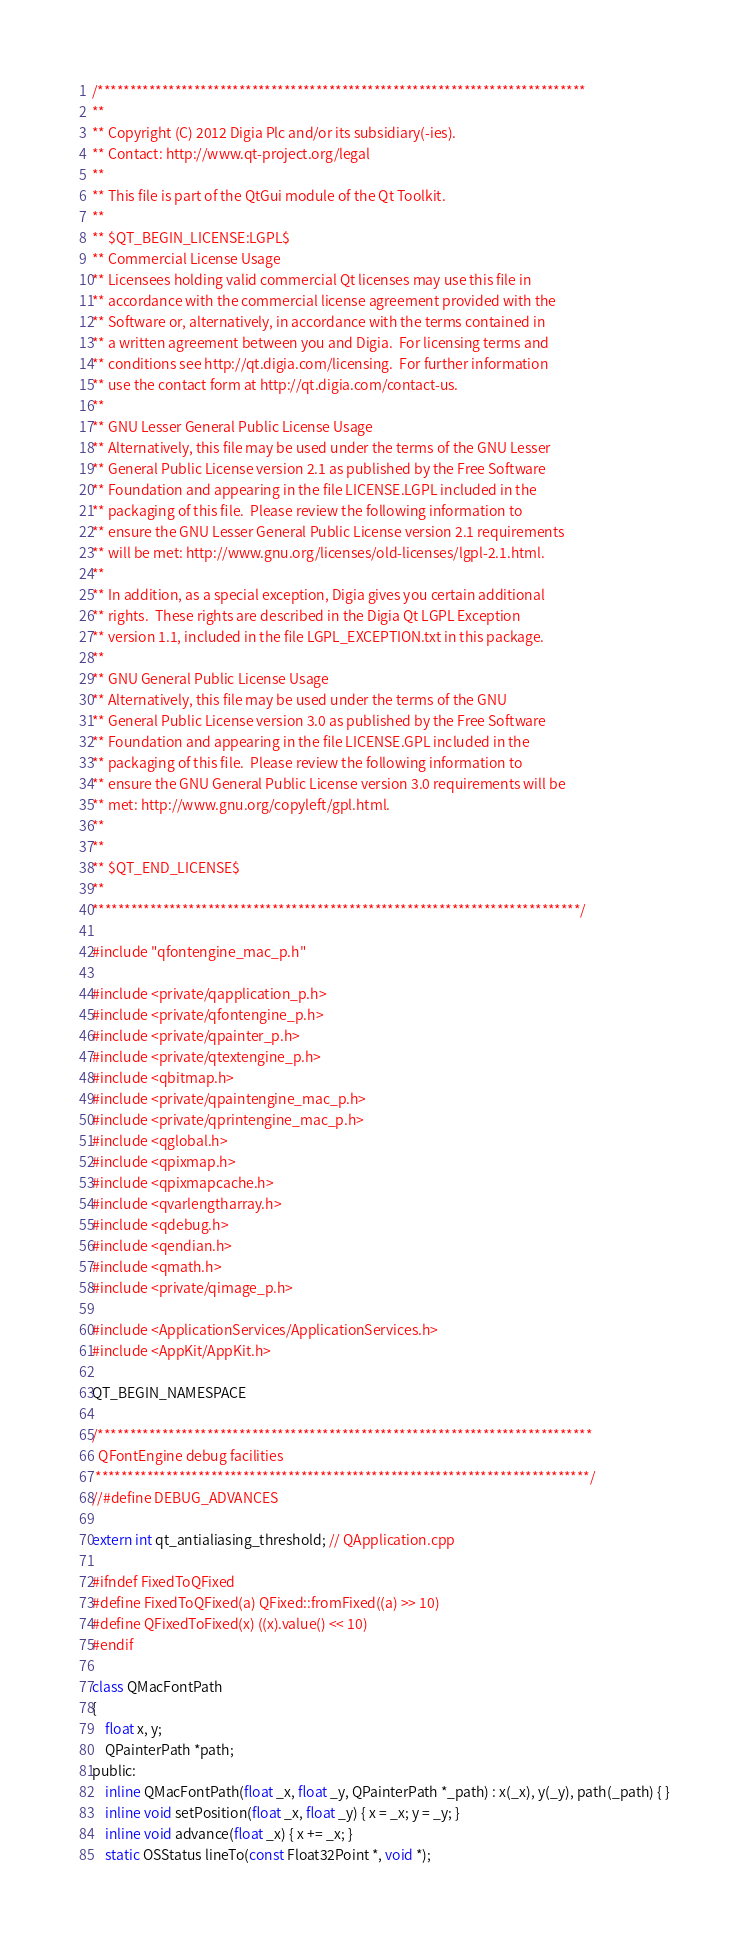Convert code to text. <code><loc_0><loc_0><loc_500><loc_500><_ObjectiveC_>/****************************************************************************
**
** Copyright (C) 2012 Digia Plc and/or its subsidiary(-ies).
** Contact: http://www.qt-project.org/legal
**
** This file is part of the QtGui module of the Qt Toolkit.
**
** $QT_BEGIN_LICENSE:LGPL$
** Commercial License Usage
** Licensees holding valid commercial Qt licenses may use this file in
** accordance with the commercial license agreement provided with the
** Software or, alternatively, in accordance with the terms contained in
** a written agreement between you and Digia.  For licensing terms and
** conditions see http://qt.digia.com/licensing.  For further information
** use the contact form at http://qt.digia.com/contact-us.
**
** GNU Lesser General Public License Usage
** Alternatively, this file may be used under the terms of the GNU Lesser
** General Public License version 2.1 as published by the Free Software
** Foundation and appearing in the file LICENSE.LGPL included in the
** packaging of this file.  Please review the following information to
** ensure the GNU Lesser General Public License version 2.1 requirements
** will be met: http://www.gnu.org/licenses/old-licenses/lgpl-2.1.html.
**
** In addition, as a special exception, Digia gives you certain additional
** rights.  These rights are described in the Digia Qt LGPL Exception
** version 1.1, included in the file LGPL_EXCEPTION.txt in this package.
**
** GNU General Public License Usage
** Alternatively, this file may be used under the terms of the GNU
** General Public License version 3.0 as published by the Free Software
** Foundation and appearing in the file LICENSE.GPL included in the
** packaging of this file.  Please review the following information to
** ensure the GNU General Public License version 3.0 requirements will be
** met: http://www.gnu.org/copyleft/gpl.html.
**
**
** $QT_END_LICENSE$
**
****************************************************************************/

#include "qfontengine_mac_p.h"

#include <private/qapplication_p.h>
#include <private/qfontengine_p.h>
#include <private/qpainter_p.h>
#include <private/qtextengine_p.h>
#include <qbitmap.h>
#include <private/qpaintengine_mac_p.h>
#include <private/qprintengine_mac_p.h>
#include <qglobal.h>
#include <qpixmap.h>
#include <qpixmapcache.h>
#include <qvarlengtharray.h>
#include <qdebug.h>
#include <qendian.h>
#include <qmath.h>
#include <private/qimage_p.h>

#include <ApplicationServices/ApplicationServices.h>
#include <AppKit/AppKit.h>

QT_BEGIN_NAMESPACE

/*****************************************************************************
  QFontEngine debug facilities
 *****************************************************************************/
//#define DEBUG_ADVANCES

extern int qt_antialiasing_threshold; // QApplication.cpp

#ifndef FixedToQFixed
#define FixedToQFixed(a) QFixed::fromFixed((a) >> 10)
#define QFixedToFixed(x) ((x).value() << 10)
#endif

class QMacFontPath
{
    float x, y;
    QPainterPath *path;
public:
    inline QMacFontPath(float _x, float _y, QPainterPath *_path) : x(_x), y(_y), path(_path) { }
    inline void setPosition(float _x, float _y) { x = _x; y = _y; }
    inline void advance(float _x) { x += _x; }
    static OSStatus lineTo(const Float32Point *, void *);</code> 